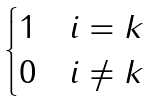Convert formula to latex. <formula><loc_0><loc_0><loc_500><loc_500>\begin{cases} 1 & i = k \\ 0 & i \ne k \end{cases}</formula> 